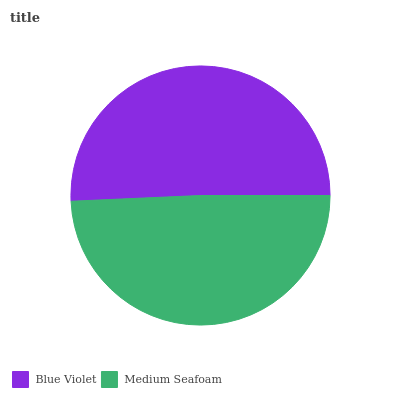Is Medium Seafoam the minimum?
Answer yes or no. Yes. Is Blue Violet the maximum?
Answer yes or no. Yes. Is Medium Seafoam the maximum?
Answer yes or no. No. Is Blue Violet greater than Medium Seafoam?
Answer yes or no. Yes. Is Medium Seafoam less than Blue Violet?
Answer yes or no. Yes. Is Medium Seafoam greater than Blue Violet?
Answer yes or no. No. Is Blue Violet less than Medium Seafoam?
Answer yes or no. No. Is Blue Violet the high median?
Answer yes or no. Yes. Is Medium Seafoam the low median?
Answer yes or no. Yes. Is Medium Seafoam the high median?
Answer yes or no. No. Is Blue Violet the low median?
Answer yes or no. No. 